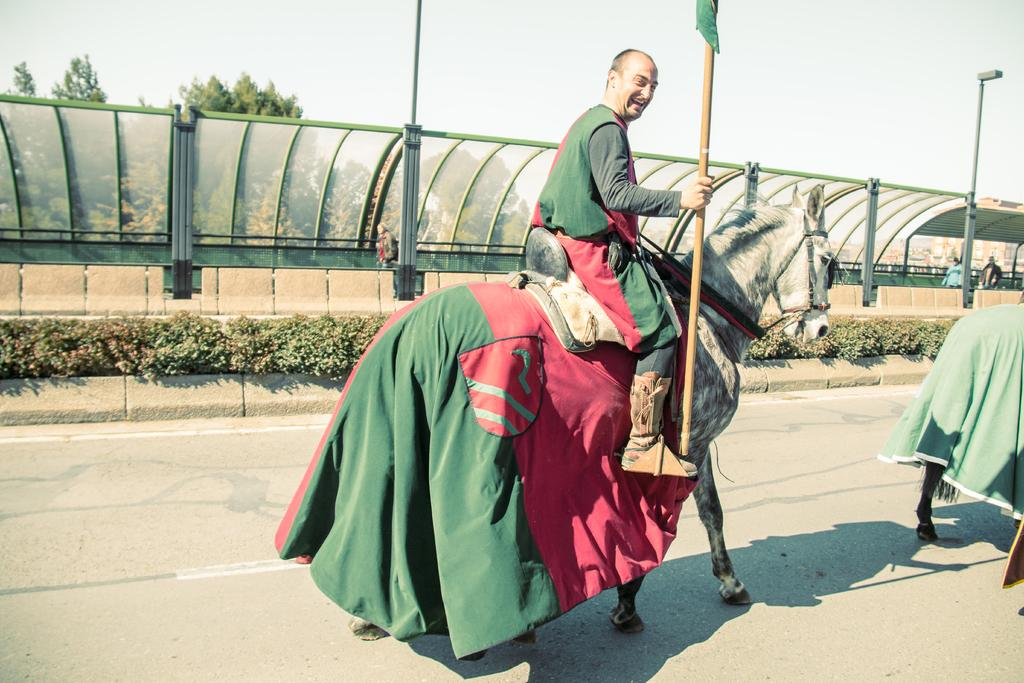What is the main subject of the image? There is a man in the image. What is the man doing in the image? The man is riding a horse in the image. Where are the horse and rider located? The horse and rider are on a road in the image. What can be seen on the left side of the image? There is a metal fence on the left side of the image. What type of vegetation is visible in the image? There are trees visible in the image. What other object can be seen in the image? There is a pole in the image. What type of growth can be seen on the horse's back in the image? There is no growth visible on the horse's back in the image. What type of farmer is present in the image? There is no farmer present in the image; it features a man riding a horse. What type of skate is being used by the man in the image? The man is riding a horse, not a skate, in the image. 